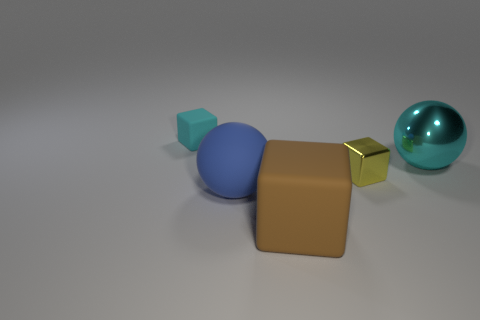What number of objects are small gray rubber cubes or large objects that are behind the blue rubber sphere?
Your answer should be very brief. 1. Are the yellow block and the cyan block made of the same material?
Your answer should be compact. No. How many other things are there of the same shape as the tiny yellow thing?
Offer a very short reply. 2. How big is the cube that is both left of the yellow metallic object and to the right of the blue ball?
Your answer should be very brief. Large. How many matte objects are either yellow things or blocks?
Offer a terse response. 2. There is a small thing that is on the right side of the tiny cyan cube; is its shape the same as the big object left of the large rubber block?
Your response must be concise. No. Are there any small gray objects made of the same material as the large block?
Provide a short and direct response. No. What color is the big shiny sphere?
Make the answer very short. Cyan. There is a cube behind the large shiny thing; what size is it?
Provide a succinct answer. Small. How many large matte balls are the same color as the large shiny thing?
Your answer should be very brief. 0. 